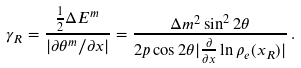Convert formula to latex. <formula><loc_0><loc_0><loc_500><loc_500>\gamma _ { R } = \frac { \frac { 1 } { 2 } \Delta E ^ { m } } { | { \partial \theta ^ { m } } / { \partial x } | } = \frac { \Delta m ^ { 2 } \sin ^ { 2 } 2 \theta } { 2 p \cos 2 \theta | \frac { \partial } { \partial x } \ln \rho _ { e } ( x _ { R } ) | } \, .</formula> 